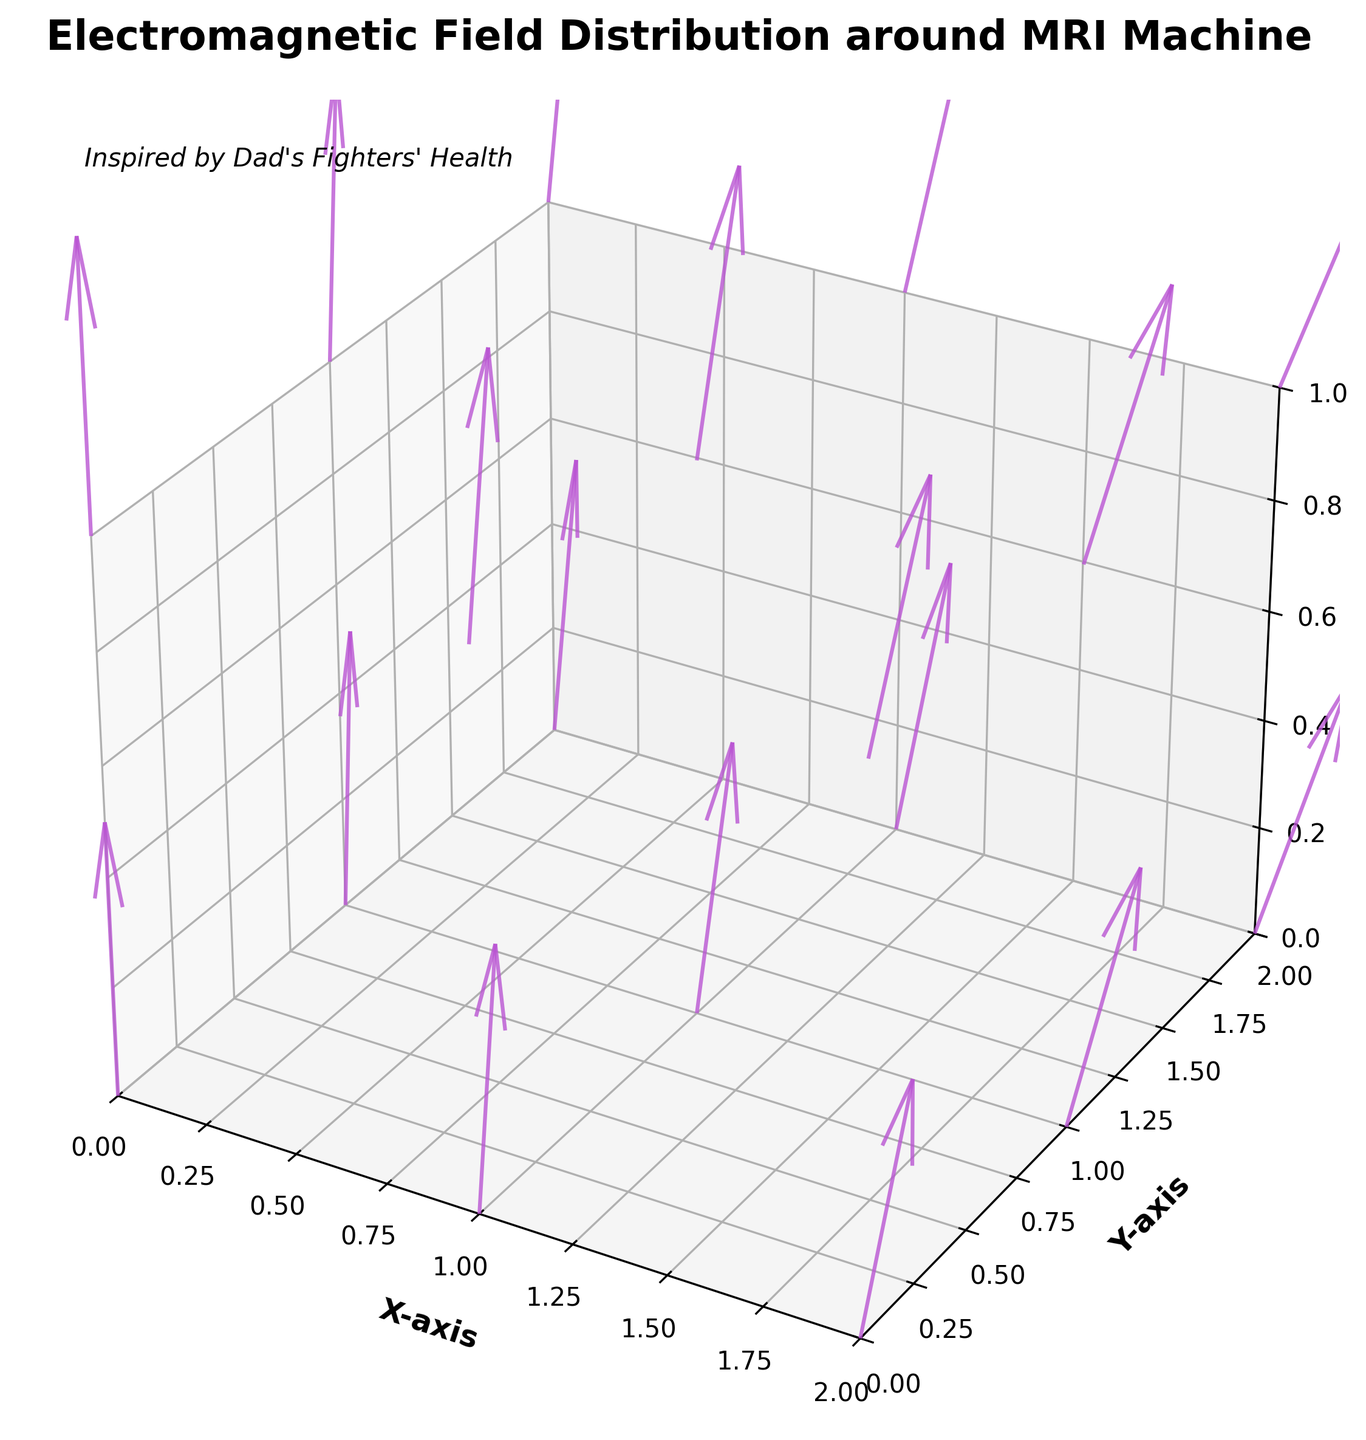What's the title of the plot? The title is placed at the top center of the figure. It reads "Electromagnetic Field Distribution around MRI Machine."
Answer: Electromagnetic Field Distribution around MRI Machine What color are the arrows in the plot? The color of the arrows can be seen directly from their appearance in the figure. They are colored in mediumorchid.
Answer: Mediumorchid What do the X, Y, and Z axes represent in the plot? The labels on the axes indicate what they represent. The X-axis is for 'X-axis', the Y-axis is for 'Y-axis', and the Z-axis is for 'Z-axis'.
Answer: X-axis, Y-axis, Z-axis How many data points are displayed in the plot? By counting each position (x, y, z) with its respective vector (Ex, Ey, Ez), we can see there are 18 unique data points corresponding to each vector.
Answer: 18 What is the maximum value on the Z-axis? The maximum value on the Z-axis can be inferred from the z-limits set in the plot, extending up to 1.
Answer: 1 How does the electromagnetic field vector change along the Z=0 plane while moving from (x=0, y=0) to (x=2, y=0)? Observing the vectors, we see they change from (0,0,5) to (1,0,4) via intermediate points. This shows the Ex value increases and the Ez value slightly decreases as x increases at y=0.
Answer: Ex increases, Ez decreases Which axis has the highest average electromagnetic field component based on their vectors? Calculate the average of each component (Ex, Ey, Ez). For Ex, sum is 9.5; for Ey, sum is 7; for Ez, sum is 60. Average is greatest for Ez.
Answer: Ez In which regions does the electromagnetic field point upwards (i.e., positive Ez)? By observing the figure, we can see that all vectors have the Ez component positive, indicating upward direction in all regions.
Answer: All regions What is the length of the vectors in the figure? The length is given as a constant in the code which is set to 0.5 units for all vectors.
Answer: 0.5 units 